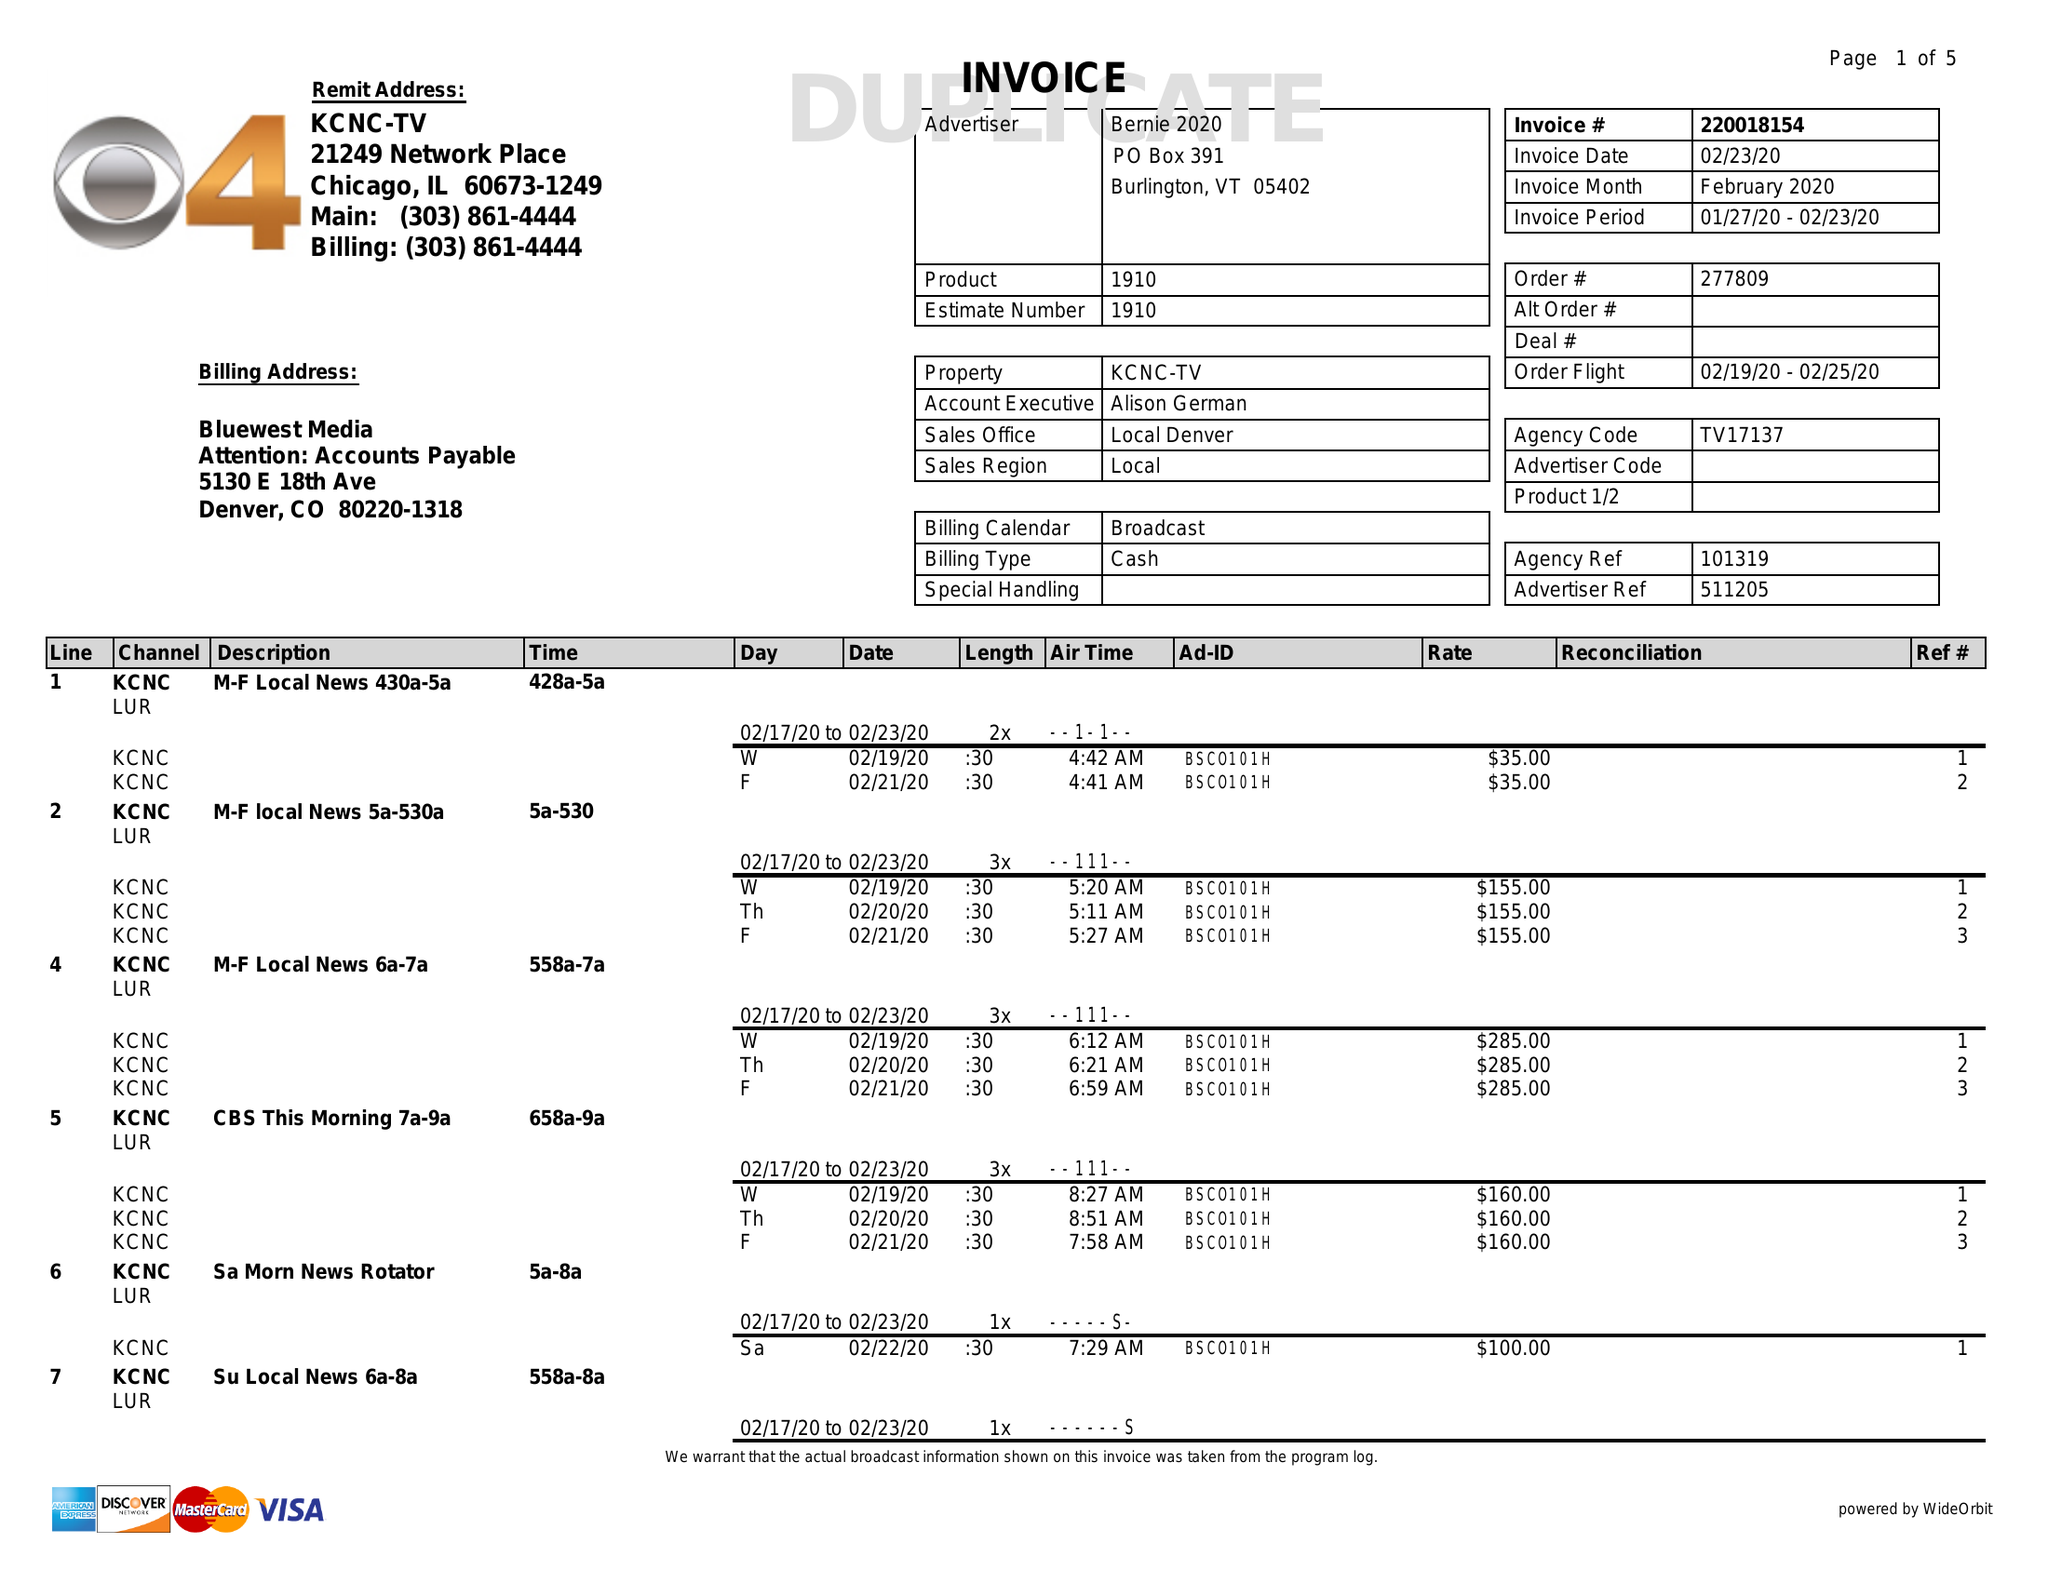What is the value for the gross_amount?
Answer the question using a single word or phrase. 19890.00 